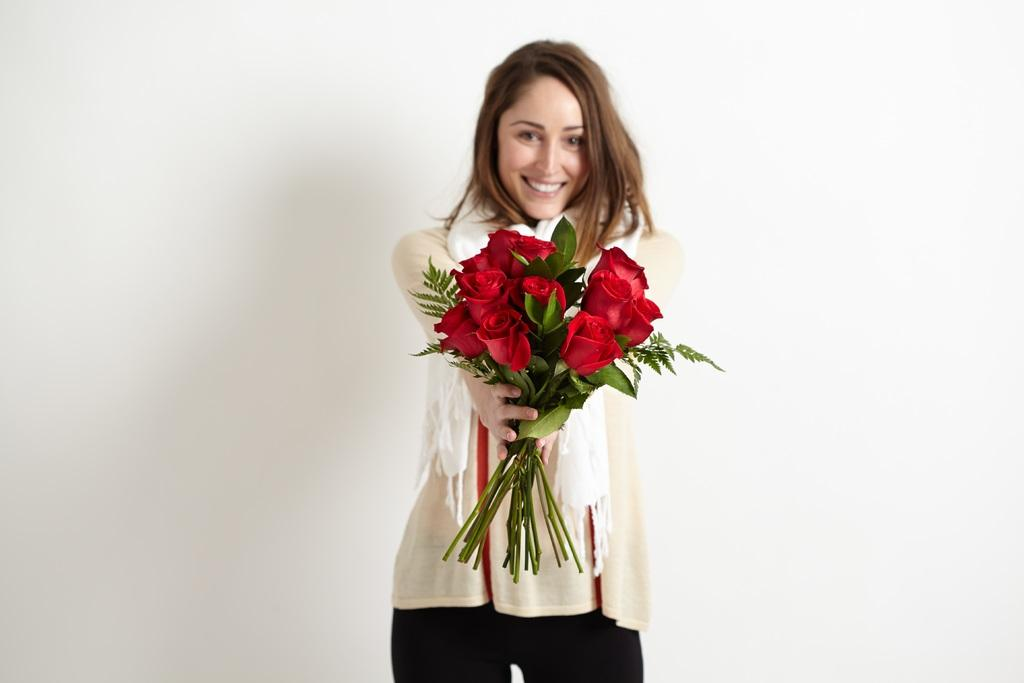Who is the main subject in the image? There is a woman in the image. What is the woman holding in the image? The woman is holding flowers. What is the color of the background in the image? The background of the image is white. What type of plastic is covering the tent in the image? There is no tent or plastic present in the image; it features a woman holding flowers against a white background. 